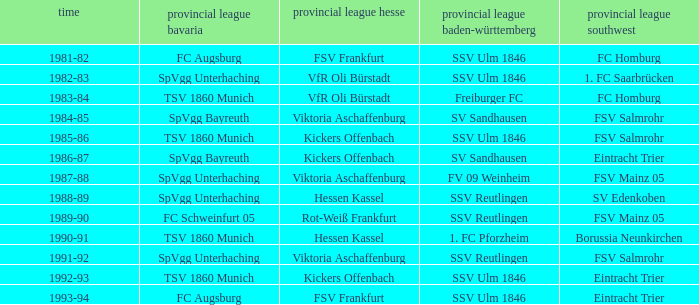Which Oberliga Bayern has a Season of 1981-82? FC Augsburg. 